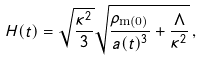<formula> <loc_0><loc_0><loc_500><loc_500>H ( t ) = \sqrt { \frac { \kappa ^ { 2 } } { 3 } } \sqrt { \frac { \rho _ { \text {m(0)} } } { a ( t ) ^ { 3 } } + \frac { \Lambda } { \kappa ^ { 2 } } } \, ,</formula> 